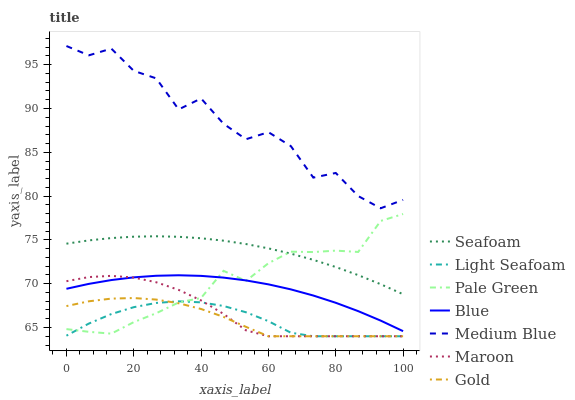Does Light Seafoam have the minimum area under the curve?
Answer yes or no. Yes. Does Medium Blue have the maximum area under the curve?
Answer yes or no. Yes. Does Gold have the minimum area under the curve?
Answer yes or no. No. Does Gold have the maximum area under the curve?
Answer yes or no. No. Is Seafoam the smoothest?
Answer yes or no. Yes. Is Medium Blue the roughest?
Answer yes or no. Yes. Is Gold the smoothest?
Answer yes or no. No. Is Gold the roughest?
Answer yes or no. No. Does Medium Blue have the lowest value?
Answer yes or no. No. Does Medium Blue have the highest value?
Answer yes or no. Yes. Does Gold have the highest value?
Answer yes or no. No. Is Maroon less than Seafoam?
Answer yes or no. Yes. Is Seafoam greater than Gold?
Answer yes or no. Yes. Does Seafoam intersect Pale Green?
Answer yes or no. Yes. Is Seafoam less than Pale Green?
Answer yes or no. No. Is Seafoam greater than Pale Green?
Answer yes or no. No. Does Maroon intersect Seafoam?
Answer yes or no. No. 